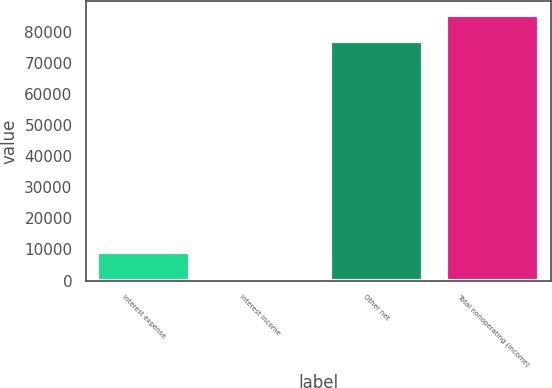Convert chart to OTSL. <chart><loc_0><loc_0><loc_500><loc_500><bar_chart><fcel>Interest expense<fcel>Interest income<fcel>Other net<fcel>Total nonoperating (income)<nl><fcel>9060.7<fcel>580<fcel>77125<fcel>85605.7<nl></chart> 